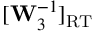Convert formula to latex. <formula><loc_0><loc_0><loc_500><loc_500>[ W _ { 3 } ^ { - 1 } ] _ { R T }</formula> 